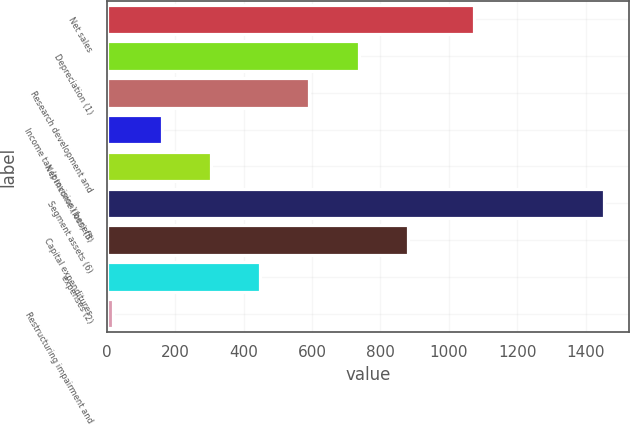Convert chart. <chart><loc_0><loc_0><loc_500><loc_500><bar_chart><fcel>Net sales<fcel>Depreciation (1)<fcel>Research development and<fcel>Income tax (provision) benefit<fcel>Net income (loss) (5)<fcel>Segment assets (6)<fcel>Capital expenditures<fcel>expenses (2)<fcel>Restructuring impairment and<nl><fcel>1074<fcel>736<fcel>592.2<fcel>160.8<fcel>304.6<fcel>1455<fcel>879.8<fcel>448.4<fcel>17<nl></chart> 